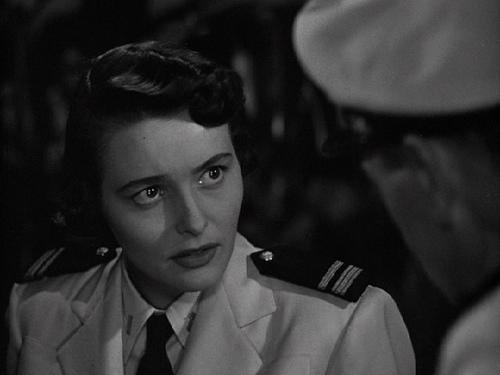How many people can you see?
Give a very brief answer. 2. 